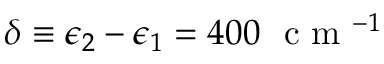Convert formula to latex. <formula><loc_0><loc_0><loc_500><loc_500>\delta \equiv \epsilon _ { 2 } - \epsilon _ { 1 } = 4 0 0 c m ^ { - 1 }</formula> 